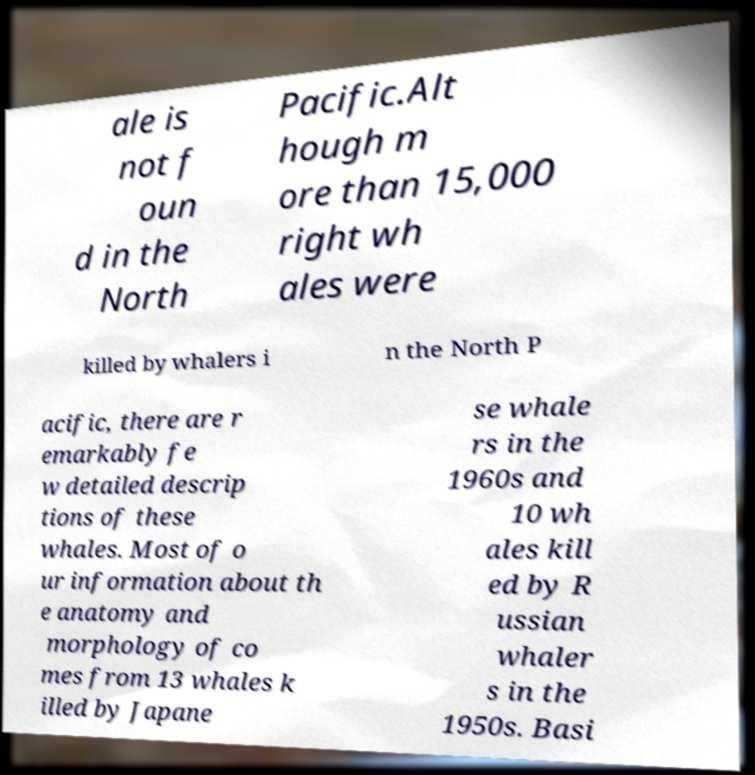Could you assist in decoding the text presented in this image and type it out clearly? ale is not f oun d in the North Pacific.Alt hough m ore than 15,000 right wh ales were killed by whalers i n the North P acific, there are r emarkably fe w detailed descrip tions of these whales. Most of o ur information about th e anatomy and morphology of co mes from 13 whales k illed by Japane se whale rs in the 1960s and 10 wh ales kill ed by R ussian whaler s in the 1950s. Basi 